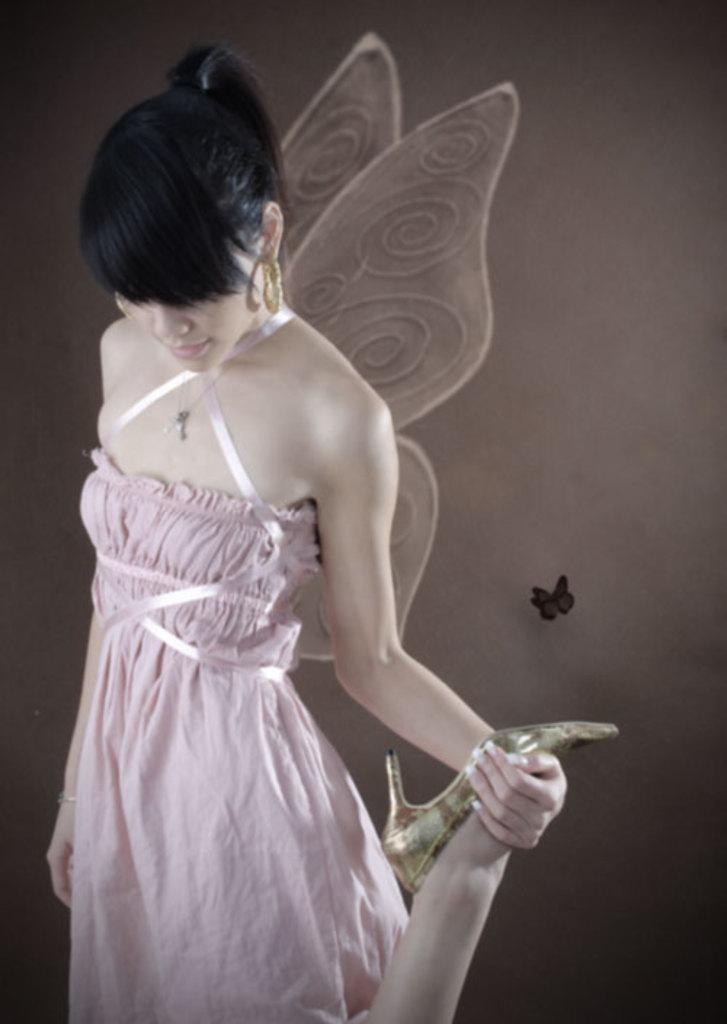What is the main subject of the image? There is a woman with wings in the image. What is the woman doing in the image? The woman is standing and holding her leg. What can be seen in the background of the image? There is a butterfly on the wall in the background of the image. How many horses are present in the image? There are no horses present in the image. What type of dogs can be seen playing with the butterfly in the image? There are no dogs present in the image, and the butterfly is on the wall, not being played with. 